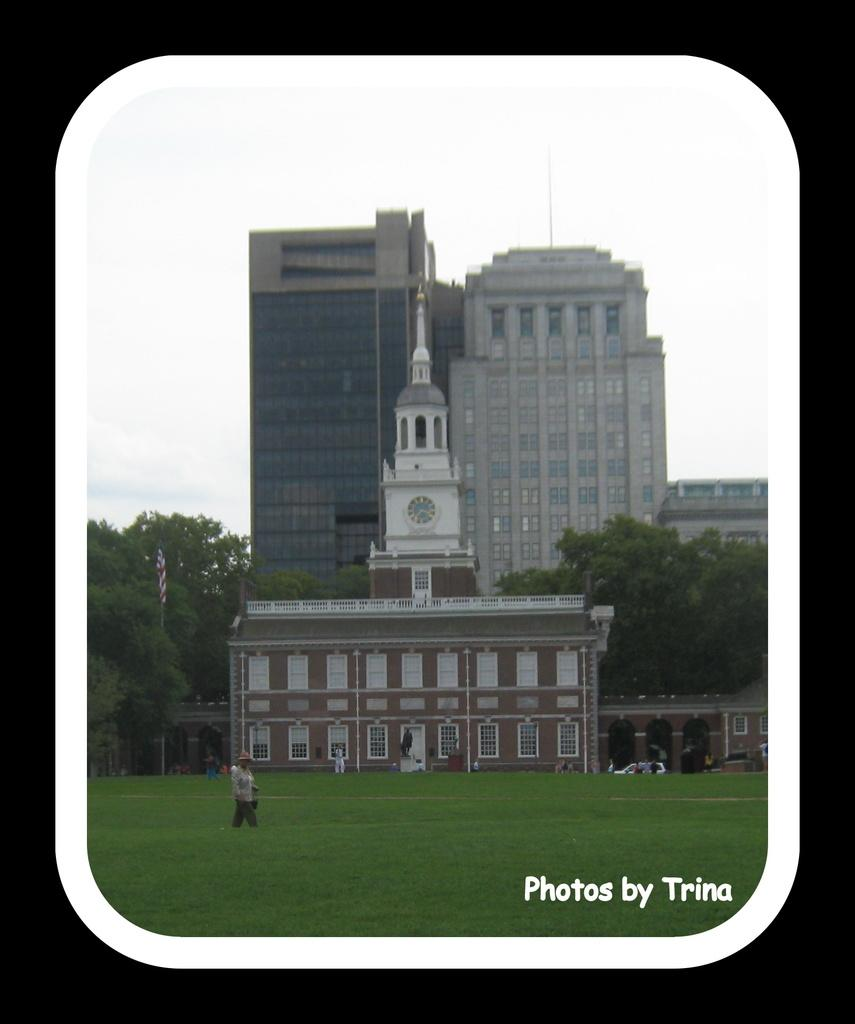What object can be seen in the image that is typically used for displaying photos? There is a photo frame in the image. What type of vegetation is visible in the image? There is green grass visible in the image. What type of structures can be seen in the image? There are buildings in the image. What type of natural elements are present in the image? There are trees in the image. Who or what is present in the image? There are people in the image. What is visible in the sky in the image? There are clouds in the sky in the image. How many rabbits can be seen playing with a flower in the image? There are no rabbits or flowers present in the image. What is the boy doing in the image? There is no boy present in the image. 